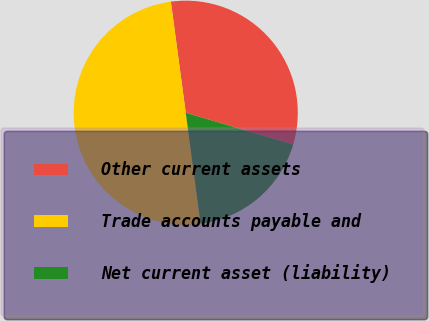Convert chart to OTSL. <chart><loc_0><loc_0><loc_500><loc_500><pie_chart><fcel>Other current assets<fcel>Trade accounts payable and<fcel>Net current asset (liability)<nl><fcel>31.69%<fcel>50.0%<fcel>18.31%<nl></chart> 